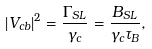Convert formula to latex. <formula><loc_0><loc_0><loc_500><loc_500>\left | V _ { c b } \right | ^ { 2 } = \frac { \Gamma _ { S L } } { \gamma _ { c } } = \frac { B _ { S L } } { \gamma _ { c } \tau _ { B } } ,</formula> 